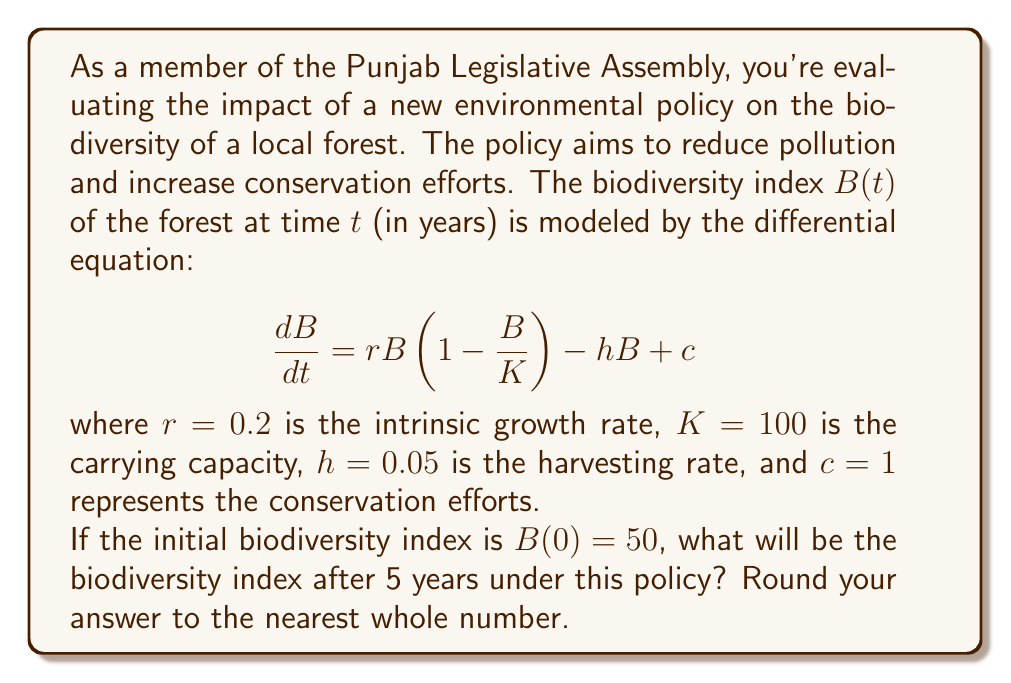Can you answer this question? To solve this problem, we need to use numerical methods to approximate the solution of the differential equation, as it doesn't have a simple analytical solution. We'll use the Euler method with a small step size to estimate the biodiversity index after 5 years.

1) The differential equation is:
   $$\frac{dB}{dt} = 0.2B(1 - \frac{B}{100}) - 0.05B + 1$$

2) We'll use a step size of $\Delta t = 0.1$ years. This means we need to perform 50 iterations to cover 5 years.

3) The Euler method formula is:
   $$B_{n+1} = B_n + \Delta t \cdot f(B_n)$$
   where $f(B) = 0.2B(1 - \frac{B}{100}) - 0.05B + 1$

4) Starting with $B_0 = 50$, we iterate:

   $B_1 = 50 + 0.1 \cdot (0.2 \cdot 50(1 - \frac{50}{100}) - 0.05 \cdot 50 + 1) = 50.35$
   
   $B_2 = 50.35 + 0.1 \cdot (0.2 \cdot 50.35(1 - \frac{50.35}{100}) - 0.05 \cdot 50.35 + 1) = 50.6965$
   
   ...

5) After 50 iterations, we get:
   $B_{50} \approx 62.8741$

6) Rounding to the nearest whole number, we get 63.
Answer: 63 